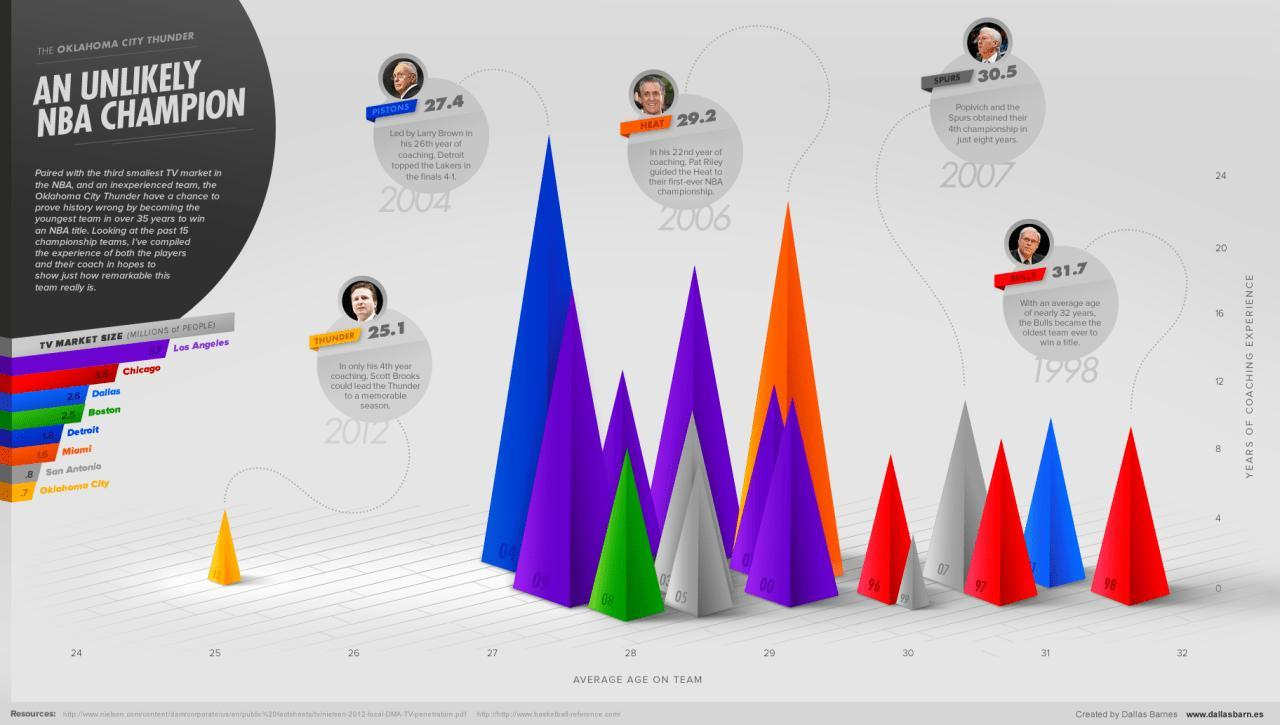Which 3 teams have the highest TV market in the NBA?
Answer the question with a short phrase. Los Angeles, Chicago, Dallas In which year did Heat win their first ever NBA championship? 2006 In which year did Thunder receive the championship, under the leadership of Scott Brooks? 2012 Which 3 teams have the lowest TV market in the NBA? Miami, San Antonio, Oklahoma City Which team has the highest average age? Bulls Which team did Pat Riley lead? Heat Which was the oldest team to win an NBA title? Bulls Which team is youngest? Thunder What is the average age of Heat? 29.2 Who is the coach of Oklahoma City Thunder? Scott Brooks Who was the coach of Spurs? Popivich What is the average age of Spurs? 30.5 